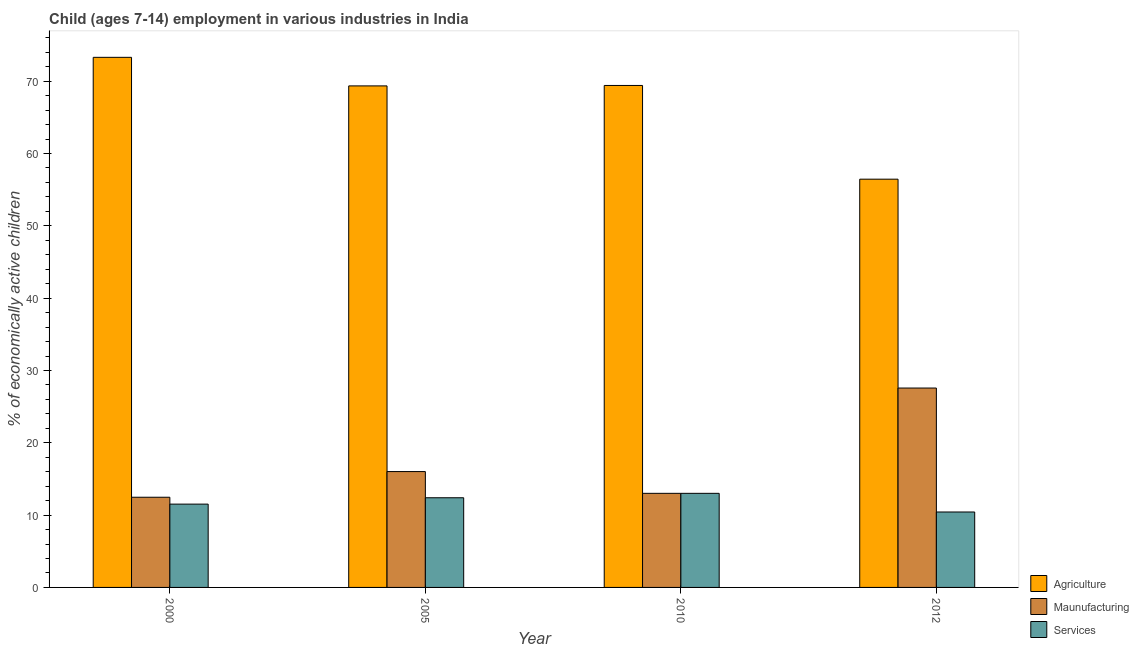How many groups of bars are there?
Your answer should be compact. 4. Are the number of bars per tick equal to the number of legend labels?
Your answer should be very brief. Yes. How many bars are there on the 3rd tick from the left?
Make the answer very short. 3. How many bars are there on the 3rd tick from the right?
Provide a succinct answer. 3. What is the label of the 1st group of bars from the left?
Provide a succinct answer. 2000. In how many cases, is the number of bars for a given year not equal to the number of legend labels?
Offer a very short reply. 0. What is the percentage of economically active children in agriculture in 2000?
Offer a terse response. 73.3. Across all years, what is the maximum percentage of economically active children in manufacturing?
Offer a terse response. 27.57. Across all years, what is the minimum percentage of economically active children in services?
Offer a very short reply. 10.43. In which year was the percentage of economically active children in services maximum?
Ensure brevity in your answer.  2010. In which year was the percentage of economically active children in agriculture minimum?
Make the answer very short. 2012. What is the total percentage of economically active children in services in the graph?
Ensure brevity in your answer.  47.36. What is the difference between the percentage of economically active children in services in 2005 and that in 2010?
Keep it short and to the point. -0.61. What is the difference between the percentage of economically active children in manufacturing in 2010 and the percentage of economically active children in agriculture in 2005?
Provide a succinct answer. -3.01. What is the average percentage of economically active children in agriculture per year?
Ensure brevity in your answer.  67.13. In how many years, is the percentage of economically active children in manufacturing greater than 4 %?
Ensure brevity in your answer.  4. What is the ratio of the percentage of economically active children in manufacturing in 2000 to that in 2005?
Provide a short and direct response. 0.78. Is the percentage of economically active children in services in 2005 less than that in 2010?
Offer a very short reply. Yes. Is the difference between the percentage of economically active children in manufacturing in 2000 and 2012 greater than the difference between the percentage of economically active children in agriculture in 2000 and 2012?
Keep it short and to the point. No. What is the difference between the highest and the second highest percentage of economically active children in agriculture?
Your answer should be very brief. 3.89. What is the difference between the highest and the lowest percentage of economically active children in manufacturing?
Your answer should be compact. 15.1. What does the 2nd bar from the left in 2010 represents?
Your answer should be compact. Maunufacturing. What does the 3rd bar from the right in 2010 represents?
Provide a short and direct response. Agriculture. Are all the bars in the graph horizontal?
Make the answer very short. No. What is the difference between two consecutive major ticks on the Y-axis?
Offer a very short reply. 10. Does the graph contain any zero values?
Offer a very short reply. No. Where does the legend appear in the graph?
Make the answer very short. Bottom right. How many legend labels are there?
Offer a terse response. 3. How are the legend labels stacked?
Ensure brevity in your answer.  Vertical. What is the title of the graph?
Your answer should be very brief. Child (ages 7-14) employment in various industries in India. Does "Oil" appear as one of the legend labels in the graph?
Offer a very short reply. No. What is the label or title of the Y-axis?
Your answer should be compact. % of economically active children. What is the % of economically active children of Agriculture in 2000?
Make the answer very short. 73.3. What is the % of economically active children in Maunufacturing in 2000?
Offer a terse response. 12.47. What is the % of economically active children of Services in 2000?
Your answer should be very brief. 11.52. What is the % of economically active children in Agriculture in 2005?
Offer a terse response. 69.35. What is the % of economically active children of Maunufacturing in 2005?
Your response must be concise. 16.02. What is the % of economically active children in Services in 2005?
Make the answer very short. 12.4. What is the % of economically active children in Agriculture in 2010?
Ensure brevity in your answer.  69.41. What is the % of economically active children of Maunufacturing in 2010?
Your answer should be very brief. 13.01. What is the % of economically active children of Services in 2010?
Keep it short and to the point. 13.01. What is the % of economically active children of Agriculture in 2012?
Ensure brevity in your answer.  56.45. What is the % of economically active children in Maunufacturing in 2012?
Provide a succinct answer. 27.57. What is the % of economically active children in Services in 2012?
Your response must be concise. 10.43. Across all years, what is the maximum % of economically active children of Agriculture?
Offer a very short reply. 73.3. Across all years, what is the maximum % of economically active children in Maunufacturing?
Your answer should be compact. 27.57. Across all years, what is the maximum % of economically active children in Services?
Your answer should be compact. 13.01. Across all years, what is the minimum % of economically active children in Agriculture?
Offer a terse response. 56.45. Across all years, what is the minimum % of economically active children of Maunufacturing?
Provide a succinct answer. 12.47. Across all years, what is the minimum % of economically active children in Services?
Offer a terse response. 10.43. What is the total % of economically active children in Agriculture in the graph?
Your answer should be very brief. 268.51. What is the total % of economically active children in Maunufacturing in the graph?
Offer a terse response. 69.07. What is the total % of economically active children of Services in the graph?
Keep it short and to the point. 47.36. What is the difference between the % of economically active children in Agriculture in 2000 and that in 2005?
Ensure brevity in your answer.  3.95. What is the difference between the % of economically active children in Maunufacturing in 2000 and that in 2005?
Ensure brevity in your answer.  -3.55. What is the difference between the % of economically active children of Services in 2000 and that in 2005?
Provide a succinct answer. -0.88. What is the difference between the % of economically active children in Agriculture in 2000 and that in 2010?
Keep it short and to the point. 3.89. What is the difference between the % of economically active children in Maunufacturing in 2000 and that in 2010?
Your answer should be very brief. -0.54. What is the difference between the % of economically active children in Services in 2000 and that in 2010?
Keep it short and to the point. -1.49. What is the difference between the % of economically active children in Agriculture in 2000 and that in 2012?
Your response must be concise. 16.85. What is the difference between the % of economically active children in Maunufacturing in 2000 and that in 2012?
Your answer should be compact. -15.1. What is the difference between the % of economically active children of Services in 2000 and that in 2012?
Your answer should be compact. 1.09. What is the difference between the % of economically active children of Agriculture in 2005 and that in 2010?
Offer a very short reply. -0.06. What is the difference between the % of economically active children in Maunufacturing in 2005 and that in 2010?
Give a very brief answer. 3.01. What is the difference between the % of economically active children in Services in 2005 and that in 2010?
Provide a short and direct response. -0.61. What is the difference between the % of economically active children in Maunufacturing in 2005 and that in 2012?
Keep it short and to the point. -11.55. What is the difference between the % of economically active children of Services in 2005 and that in 2012?
Give a very brief answer. 1.97. What is the difference between the % of economically active children in Agriculture in 2010 and that in 2012?
Ensure brevity in your answer.  12.96. What is the difference between the % of economically active children of Maunufacturing in 2010 and that in 2012?
Your answer should be very brief. -14.56. What is the difference between the % of economically active children in Services in 2010 and that in 2012?
Offer a terse response. 2.58. What is the difference between the % of economically active children in Agriculture in 2000 and the % of economically active children in Maunufacturing in 2005?
Keep it short and to the point. 57.28. What is the difference between the % of economically active children in Agriculture in 2000 and the % of economically active children in Services in 2005?
Provide a short and direct response. 60.9. What is the difference between the % of economically active children of Maunufacturing in 2000 and the % of economically active children of Services in 2005?
Your answer should be compact. 0.07. What is the difference between the % of economically active children in Agriculture in 2000 and the % of economically active children in Maunufacturing in 2010?
Provide a short and direct response. 60.29. What is the difference between the % of economically active children in Agriculture in 2000 and the % of economically active children in Services in 2010?
Ensure brevity in your answer.  60.29. What is the difference between the % of economically active children of Maunufacturing in 2000 and the % of economically active children of Services in 2010?
Give a very brief answer. -0.54. What is the difference between the % of economically active children of Agriculture in 2000 and the % of economically active children of Maunufacturing in 2012?
Offer a terse response. 45.73. What is the difference between the % of economically active children of Agriculture in 2000 and the % of economically active children of Services in 2012?
Give a very brief answer. 62.87. What is the difference between the % of economically active children in Maunufacturing in 2000 and the % of economically active children in Services in 2012?
Offer a very short reply. 2.04. What is the difference between the % of economically active children in Agriculture in 2005 and the % of economically active children in Maunufacturing in 2010?
Offer a very short reply. 56.34. What is the difference between the % of economically active children of Agriculture in 2005 and the % of economically active children of Services in 2010?
Offer a terse response. 56.34. What is the difference between the % of economically active children of Maunufacturing in 2005 and the % of economically active children of Services in 2010?
Your response must be concise. 3.01. What is the difference between the % of economically active children in Agriculture in 2005 and the % of economically active children in Maunufacturing in 2012?
Make the answer very short. 41.78. What is the difference between the % of economically active children of Agriculture in 2005 and the % of economically active children of Services in 2012?
Make the answer very short. 58.92. What is the difference between the % of economically active children in Maunufacturing in 2005 and the % of economically active children in Services in 2012?
Provide a succinct answer. 5.59. What is the difference between the % of economically active children in Agriculture in 2010 and the % of economically active children in Maunufacturing in 2012?
Provide a short and direct response. 41.84. What is the difference between the % of economically active children of Agriculture in 2010 and the % of economically active children of Services in 2012?
Provide a short and direct response. 58.98. What is the difference between the % of economically active children in Maunufacturing in 2010 and the % of economically active children in Services in 2012?
Make the answer very short. 2.58. What is the average % of economically active children of Agriculture per year?
Keep it short and to the point. 67.13. What is the average % of economically active children in Maunufacturing per year?
Make the answer very short. 17.27. What is the average % of economically active children of Services per year?
Your answer should be very brief. 11.84. In the year 2000, what is the difference between the % of economically active children in Agriculture and % of economically active children in Maunufacturing?
Provide a succinct answer. 60.83. In the year 2000, what is the difference between the % of economically active children of Agriculture and % of economically active children of Services?
Keep it short and to the point. 61.78. In the year 2005, what is the difference between the % of economically active children in Agriculture and % of economically active children in Maunufacturing?
Your answer should be compact. 53.33. In the year 2005, what is the difference between the % of economically active children of Agriculture and % of economically active children of Services?
Give a very brief answer. 56.95. In the year 2005, what is the difference between the % of economically active children in Maunufacturing and % of economically active children in Services?
Your answer should be compact. 3.62. In the year 2010, what is the difference between the % of economically active children of Agriculture and % of economically active children of Maunufacturing?
Your answer should be very brief. 56.4. In the year 2010, what is the difference between the % of economically active children in Agriculture and % of economically active children in Services?
Give a very brief answer. 56.4. In the year 2012, what is the difference between the % of economically active children of Agriculture and % of economically active children of Maunufacturing?
Offer a very short reply. 28.88. In the year 2012, what is the difference between the % of economically active children in Agriculture and % of economically active children in Services?
Your answer should be very brief. 46.02. In the year 2012, what is the difference between the % of economically active children in Maunufacturing and % of economically active children in Services?
Your response must be concise. 17.14. What is the ratio of the % of economically active children of Agriculture in 2000 to that in 2005?
Provide a succinct answer. 1.06. What is the ratio of the % of economically active children in Maunufacturing in 2000 to that in 2005?
Your answer should be very brief. 0.78. What is the ratio of the % of economically active children of Services in 2000 to that in 2005?
Offer a very short reply. 0.93. What is the ratio of the % of economically active children in Agriculture in 2000 to that in 2010?
Provide a succinct answer. 1.06. What is the ratio of the % of economically active children of Maunufacturing in 2000 to that in 2010?
Ensure brevity in your answer.  0.96. What is the ratio of the % of economically active children of Services in 2000 to that in 2010?
Your answer should be compact. 0.89. What is the ratio of the % of economically active children of Agriculture in 2000 to that in 2012?
Ensure brevity in your answer.  1.3. What is the ratio of the % of economically active children in Maunufacturing in 2000 to that in 2012?
Ensure brevity in your answer.  0.45. What is the ratio of the % of economically active children in Services in 2000 to that in 2012?
Offer a very short reply. 1.1. What is the ratio of the % of economically active children in Agriculture in 2005 to that in 2010?
Keep it short and to the point. 1. What is the ratio of the % of economically active children of Maunufacturing in 2005 to that in 2010?
Keep it short and to the point. 1.23. What is the ratio of the % of economically active children in Services in 2005 to that in 2010?
Offer a terse response. 0.95. What is the ratio of the % of economically active children in Agriculture in 2005 to that in 2012?
Ensure brevity in your answer.  1.23. What is the ratio of the % of economically active children in Maunufacturing in 2005 to that in 2012?
Offer a terse response. 0.58. What is the ratio of the % of economically active children of Services in 2005 to that in 2012?
Keep it short and to the point. 1.19. What is the ratio of the % of economically active children of Agriculture in 2010 to that in 2012?
Keep it short and to the point. 1.23. What is the ratio of the % of economically active children in Maunufacturing in 2010 to that in 2012?
Provide a short and direct response. 0.47. What is the ratio of the % of economically active children in Services in 2010 to that in 2012?
Provide a succinct answer. 1.25. What is the difference between the highest and the second highest % of economically active children in Agriculture?
Your answer should be very brief. 3.89. What is the difference between the highest and the second highest % of economically active children in Maunufacturing?
Give a very brief answer. 11.55. What is the difference between the highest and the second highest % of economically active children of Services?
Ensure brevity in your answer.  0.61. What is the difference between the highest and the lowest % of economically active children in Agriculture?
Ensure brevity in your answer.  16.85. What is the difference between the highest and the lowest % of economically active children of Maunufacturing?
Offer a terse response. 15.1. What is the difference between the highest and the lowest % of economically active children in Services?
Offer a very short reply. 2.58. 